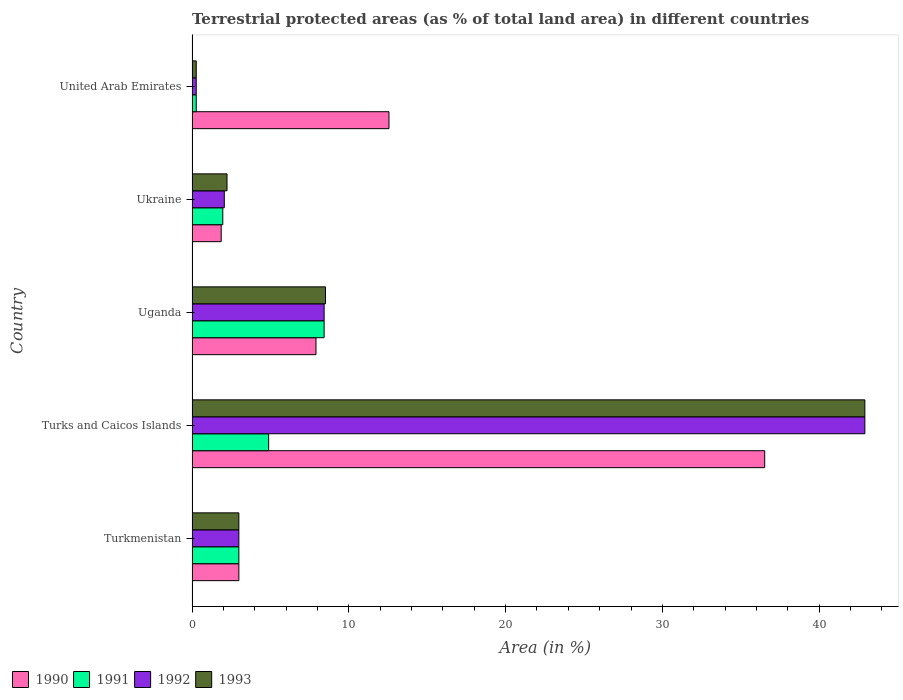Are the number of bars on each tick of the Y-axis equal?
Your answer should be very brief. Yes. How many bars are there on the 4th tick from the top?
Your answer should be compact. 4. How many bars are there on the 2nd tick from the bottom?
Give a very brief answer. 4. What is the label of the 1st group of bars from the top?
Make the answer very short. United Arab Emirates. In how many cases, is the number of bars for a given country not equal to the number of legend labels?
Provide a short and direct response. 0. What is the percentage of terrestrial protected land in 1990 in Uganda?
Your answer should be very brief. 7.91. Across all countries, what is the maximum percentage of terrestrial protected land in 1990?
Offer a terse response. 36.53. Across all countries, what is the minimum percentage of terrestrial protected land in 1992?
Make the answer very short. 0.27. In which country was the percentage of terrestrial protected land in 1990 maximum?
Offer a very short reply. Turks and Caicos Islands. In which country was the percentage of terrestrial protected land in 1992 minimum?
Provide a succinct answer. United Arab Emirates. What is the total percentage of terrestrial protected land in 1990 in the graph?
Give a very brief answer. 61.84. What is the difference between the percentage of terrestrial protected land in 1991 in Uganda and that in Ukraine?
Provide a short and direct response. 6.46. What is the difference between the percentage of terrestrial protected land in 1992 in Turkmenistan and the percentage of terrestrial protected land in 1990 in United Arab Emirates?
Ensure brevity in your answer.  -9.58. What is the average percentage of terrestrial protected land in 1993 per country?
Your answer should be very brief. 11.38. What is the difference between the percentage of terrestrial protected land in 1991 and percentage of terrestrial protected land in 1990 in Turkmenistan?
Provide a succinct answer. 1.6665444499963655e-6. In how many countries, is the percentage of terrestrial protected land in 1993 greater than 30 %?
Offer a very short reply. 1. What is the ratio of the percentage of terrestrial protected land in 1990 in Turks and Caicos Islands to that in Ukraine?
Offer a terse response. 19.65. Is the percentage of terrestrial protected land in 1993 in Turks and Caicos Islands less than that in United Arab Emirates?
Make the answer very short. No. Is the difference between the percentage of terrestrial protected land in 1991 in Turks and Caicos Islands and Uganda greater than the difference between the percentage of terrestrial protected land in 1990 in Turks and Caicos Islands and Uganda?
Your answer should be very brief. No. What is the difference between the highest and the second highest percentage of terrestrial protected land in 1990?
Your answer should be very brief. 23.97. What is the difference between the highest and the lowest percentage of terrestrial protected land in 1991?
Make the answer very short. 8.16. Is the sum of the percentage of terrestrial protected land in 1991 in Turkmenistan and Ukraine greater than the maximum percentage of terrestrial protected land in 1992 across all countries?
Ensure brevity in your answer.  No. Is it the case that in every country, the sum of the percentage of terrestrial protected land in 1992 and percentage of terrestrial protected land in 1990 is greater than the sum of percentage of terrestrial protected land in 1993 and percentage of terrestrial protected land in 1991?
Keep it short and to the point. No. Is it the case that in every country, the sum of the percentage of terrestrial protected land in 1991 and percentage of terrestrial protected land in 1993 is greater than the percentage of terrestrial protected land in 1992?
Ensure brevity in your answer.  Yes. How many countries are there in the graph?
Provide a short and direct response. 5. What is the difference between two consecutive major ticks on the X-axis?
Give a very brief answer. 10. Are the values on the major ticks of X-axis written in scientific E-notation?
Provide a short and direct response. No. How many legend labels are there?
Make the answer very short. 4. What is the title of the graph?
Give a very brief answer. Terrestrial protected areas (as % of total land area) in different countries. What is the label or title of the X-axis?
Ensure brevity in your answer.  Area (in %). What is the label or title of the Y-axis?
Your answer should be compact. Country. What is the Area (in %) of 1990 in Turkmenistan?
Offer a very short reply. 2.99. What is the Area (in %) of 1991 in Turkmenistan?
Ensure brevity in your answer.  2.99. What is the Area (in %) in 1992 in Turkmenistan?
Keep it short and to the point. 2.99. What is the Area (in %) of 1993 in Turkmenistan?
Keep it short and to the point. 2.99. What is the Area (in %) of 1990 in Turks and Caicos Islands?
Your response must be concise. 36.53. What is the Area (in %) of 1991 in Turks and Caicos Islands?
Your answer should be very brief. 4.89. What is the Area (in %) of 1992 in Turks and Caicos Islands?
Provide a succinct answer. 42.92. What is the Area (in %) of 1993 in Turks and Caicos Islands?
Keep it short and to the point. 42.92. What is the Area (in %) of 1990 in Uganda?
Give a very brief answer. 7.91. What is the Area (in %) of 1991 in Uganda?
Provide a succinct answer. 8.43. What is the Area (in %) in 1992 in Uganda?
Your answer should be compact. 8.43. What is the Area (in %) in 1993 in Uganda?
Your response must be concise. 8.51. What is the Area (in %) of 1990 in Ukraine?
Provide a succinct answer. 1.86. What is the Area (in %) in 1991 in Ukraine?
Offer a very short reply. 1.96. What is the Area (in %) in 1992 in Ukraine?
Make the answer very short. 2.06. What is the Area (in %) in 1993 in Ukraine?
Keep it short and to the point. 2.23. What is the Area (in %) in 1990 in United Arab Emirates?
Provide a succinct answer. 12.56. What is the Area (in %) in 1991 in United Arab Emirates?
Give a very brief answer. 0.27. What is the Area (in %) of 1992 in United Arab Emirates?
Your response must be concise. 0.27. What is the Area (in %) in 1993 in United Arab Emirates?
Make the answer very short. 0.27. Across all countries, what is the maximum Area (in %) in 1990?
Ensure brevity in your answer.  36.53. Across all countries, what is the maximum Area (in %) in 1991?
Keep it short and to the point. 8.43. Across all countries, what is the maximum Area (in %) of 1992?
Provide a succinct answer. 42.92. Across all countries, what is the maximum Area (in %) of 1993?
Make the answer very short. 42.92. Across all countries, what is the minimum Area (in %) in 1990?
Give a very brief answer. 1.86. Across all countries, what is the minimum Area (in %) in 1991?
Offer a terse response. 0.27. Across all countries, what is the minimum Area (in %) of 1992?
Ensure brevity in your answer.  0.27. Across all countries, what is the minimum Area (in %) in 1993?
Make the answer very short. 0.27. What is the total Area (in %) in 1990 in the graph?
Offer a terse response. 61.84. What is the total Area (in %) in 1991 in the graph?
Your answer should be compact. 18.53. What is the total Area (in %) of 1992 in the graph?
Your answer should be compact. 56.65. What is the total Area (in %) in 1993 in the graph?
Keep it short and to the point. 56.91. What is the difference between the Area (in %) in 1990 in Turkmenistan and that in Turks and Caicos Islands?
Your answer should be very brief. -33.54. What is the difference between the Area (in %) of 1991 in Turkmenistan and that in Turks and Caicos Islands?
Your answer should be compact. -1.9. What is the difference between the Area (in %) of 1992 in Turkmenistan and that in Turks and Caicos Islands?
Provide a succinct answer. -39.93. What is the difference between the Area (in %) in 1993 in Turkmenistan and that in Turks and Caicos Islands?
Ensure brevity in your answer.  -39.93. What is the difference between the Area (in %) of 1990 in Turkmenistan and that in Uganda?
Offer a terse response. -4.92. What is the difference between the Area (in %) of 1991 in Turkmenistan and that in Uganda?
Your response must be concise. -5.44. What is the difference between the Area (in %) in 1992 in Turkmenistan and that in Uganda?
Keep it short and to the point. -5.44. What is the difference between the Area (in %) in 1993 in Turkmenistan and that in Uganda?
Your answer should be very brief. -5.53. What is the difference between the Area (in %) of 1990 in Turkmenistan and that in Ukraine?
Give a very brief answer. 1.13. What is the difference between the Area (in %) of 1991 in Turkmenistan and that in Ukraine?
Make the answer very short. 1.02. What is the difference between the Area (in %) in 1992 in Turkmenistan and that in Ukraine?
Give a very brief answer. 0.93. What is the difference between the Area (in %) of 1993 in Turkmenistan and that in Ukraine?
Your answer should be compact. 0.76. What is the difference between the Area (in %) of 1990 in Turkmenistan and that in United Arab Emirates?
Ensure brevity in your answer.  -9.58. What is the difference between the Area (in %) of 1991 in Turkmenistan and that in United Arab Emirates?
Make the answer very short. 2.72. What is the difference between the Area (in %) in 1992 in Turkmenistan and that in United Arab Emirates?
Your response must be concise. 2.72. What is the difference between the Area (in %) in 1993 in Turkmenistan and that in United Arab Emirates?
Your response must be concise. 2.72. What is the difference between the Area (in %) of 1990 in Turks and Caicos Islands and that in Uganda?
Keep it short and to the point. 28.62. What is the difference between the Area (in %) in 1991 in Turks and Caicos Islands and that in Uganda?
Your response must be concise. -3.54. What is the difference between the Area (in %) in 1992 in Turks and Caicos Islands and that in Uganda?
Provide a short and direct response. 34.49. What is the difference between the Area (in %) of 1993 in Turks and Caicos Islands and that in Uganda?
Provide a short and direct response. 34.4. What is the difference between the Area (in %) in 1990 in Turks and Caicos Islands and that in Ukraine?
Make the answer very short. 34.67. What is the difference between the Area (in %) in 1991 in Turks and Caicos Islands and that in Ukraine?
Your answer should be very brief. 2.92. What is the difference between the Area (in %) in 1992 in Turks and Caicos Islands and that in Ukraine?
Your answer should be very brief. 40.86. What is the difference between the Area (in %) of 1993 in Turks and Caicos Islands and that in Ukraine?
Give a very brief answer. 40.69. What is the difference between the Area (in %) of 1990 in Turks and Caicos Islands and that in United Arab Emirates?
Your answer should be very brief. 23.97. What is the difference between the Area (in %) of 1991 in Turks and Caicos Islands and that in United Arab Emirates?
Offer a very short reply. 4.62. What is the difference between the Area (in %) of 1992 in Turks and Caicos Islands and that in United Arab Emirates?
Give a very brief answer. 42.65. What is the difference between the Area (in %) of 1993 in Turks and Caicos Islands and that in United Arab Emirates?
Make the answer very short. 42.65. What is the difference between the Area (in %) in 1990 in Uganda and that in Ukraine?
Give a very brief answer. 6.05. What is the difference between the Area (in %) of 1991 in Uganda and that in Ukraine?
Offer a very short reply. 6.46. What is the difference between the Area (in %) of 1992 in Uganda and that in Ukraine?
Your answer should be compact. 6.37. What is the difference between the Area (in %) of 1993 in Uganda and that in Ukraine?
Provide a succinct answer. 6.28. What is the difference between the Area (in %) of 1990 in Uganda and that in United Arab Emirates?
Give a very brief answer. -4.66. What is the difference between the Area (in %) of 1991 in Uganda and that in United Arab Emirates?
Your response must be concise. 8.16. What is the difference between the Area (in %) in 1992 in Uganda and that in United Arab Emirates?
Keep it short and to the point. 8.16. What is the difference between the Area (in %) in 1993 in Uganda and that in United Arab Emirates?
Make the answer very short. 8.25. What is the difference between the Area (in %) of 1990 in Ukraine and that in United Arab Emirates?
Give a very brief answer. -10.7. What is the difference between the Area (in %) in 1991 in Ukraine and that in United Arab Emirates?
Keep it short and to the point. 1.69. What is the difference between the Area (in %) in 1992 in Ukraine and that in United Arab Emirates?
Offer a very short reply. 1.79. What is the difference between the Area (in %) in 1993 in Ukraine and that in United Arab Emirates?
Offer a very short reply. 1.96. What is the difference between the Area (in %) of 1990 in Turkmenistan and the Area (in %) of 1991 in Turks and Caicos Islands?
Give a very brief answer. -1.9. What is the difference between the Area (in %) in 1990 in Turkmenistan and the Area (in %) in 1992 in Turks and Caicos Islands?
Your answer should be compact. -39.93. What is the difference between the Area (in %) of 1990 in Turkmenistan and the Area (in %) of 1993 in Turks and Caicos Islands?
Make the answer very short. -39.93. What is the difference between the Area (in %) of 1991 in Turkmenistan and the Area (in %) of 1992 in Turks and Caicos Islands?
Provide a short and direct response. -39.93. What is the difference between the Area (in %) of 1991 in Turkmenistan and the Area (in %) of 1993 in Turks and Caicos Islands?
Offer a terse response. -39.93. What is the difference between the Area (in %) in 1992 in Turkmenistan and the Area (in %) in 1993 in Turks and Caicos Islands?
Offer a very short reply. -39.93. What is the difference between the Area (in %) of 1990 in Turkmenistan and the Area (in %) of 1991 in Uganda?
Provide a short and direct response. -5.44. What is the difference between the Area (in %) of 1990 in Turkmenistan and the Area (in %) of 1992 in Uganda?
Give a very brief answer. -5.44. What is the difference between the Area (in %) of 1990 in Turkmenistan and the Area (in %) of 1993 in Uganda?
Offer a terse response. -5.53. What is the difference between the Area (in %) in 1991 in Turkmenistan and the Area (in %) in 1992 in Uganda?
Your answer should be very brief. -5.44. What is the difference between the Area (in %) in 1991 in Turkmenistan and the Area (in %) in 1993 in Uganda?
Ensure brevity in your answer.  -5.53. What is the difference between the Area (in %) in 1992 in Turkmenistan and the Area (in %) in 1993 in Uganda?
Provide a succinct answer. -5.53. What is the difference between the Area (in %) of 1990 in Turkmenistan and the Area (in %) of 1991 in Ukraine?
Provide a short and direct response. 1.02. What is the difference between the Area (in %) of 1990 in Turkmenistan and the Area (in %) of 1992 in Ukraine?
Ensure brevity in your answer.  0.93. What is the difference between the Area (in %) in 1990 in Turkmenistan and the Area (in %) in 1993 in Ukraine?
Ensure brevity in your answer.  0.76. What is the difference between the Area (in %) in 1991 in Turkmenistan and the Area (in %) in 1992 in Ukraine?
Keep it short and to the point. 0.93. What is the difference between the Area (in %) of 1991 in Turkmenistan and the Area (in %) of 1993 in Ukraine?
Offer a terse response. 0.76. What is the difference between the Area (in %) in 1992 in Turkmenistan and the Area (in %) in 1993 in Ukraine?
Make the answer very short. 0.76. What is the difference between the Area (in %) of 1990 in Turkmenistan and the Area (in %) of 1991 in United Arab Emirates?
Keep it short and to the point. 2.72. What is the difference between the Area (in %) in 1990 in Turkmenistan and the Area (in %) in 1992 in United Arab Emirates?
Provide a short and direct response. 2.72. What is the difference between the Area (in %) in 1990 in Turkmenistan and the Area (in %) in 1993 in United Arab Emirates?
Keep it short and to the point. 2.72. What is the difference between the Area (in %) of 1991 in Turkmenistan and the Area (in %) of 1992 in United Arab Emirates?
Provide a succinct answer. 2.72. What is the difference between the Area (in %) in 1991 in Turkmenistan and the Area (in %) in 1993 in United Arab Emirates?
Provide a short and direct response. 2.72. What is the difference between the Area (in %) of 1992 in Turkmenistan and the Area (in %) of 1993 in United Arab Emirates?
Provide a short and direct response. 2.72. What is the difference between the Area (in %) of 1990 in Turks and Caicos Islands and the Area (in %) of 1991 in Uganda?
Offer a terse response. 28.1. What is the difference between the Area (in %) in 1990 in Turks and Caicos Islands and the Area (in %) in 1992 in Uganda?
Ensure brevity in your answer.  28.1. What is the difference between the Area (in %) in 1990 in Turks and Caicos Islands and the Area (in %) in 1993 in Uganda?
Give a very brief answer. 28.02. What is the difference between the Area (in %) of 1991 in Turks and Caicos Islands and the Area (in %) of 1992 in Uganda?
Your answer should be compact. -3.54. What is the difference between the Area (in %) in 1991 in Turks and Caicos Islands and the Area (in %) in 1993 in Uganda?
Provide a succinct answer. -3.63. What is the difference between the Area (in %) in 1992 in Turks and Caicos Islands and the Area (in %) in 1993 in Uganda?
Your response must be concise. 34.4. What is the difference between the Area (in %) of 1990 in Turks and Caicos Islands and the Area (in %) of 1991 in Ukraine?
Keep it short and to the point. 34.57. What is the difference between the Area (in %) in 1990 in Turks and Caicos Islands and the Area (in %) in 1992 in Ukraine?
Offer a very short reply. 34.47. What is the difference between the Area (in %) of 1990 in Turks and Caicos Islands and the Area (in %) of 1993 in Ukraine?
Your answer should be compact. 34.3. What is the difference between the Area (in %) in 1991 in Turks and Caicos Islands and the Area (in %) in 1992 in Ukraine?
Your response must be concise. 2.83. What is the difference between the Area (in %) of 1991 in Turks and Caicos Islands and the Area (in %) of 1993 in Ukraine?
Give a very brief answer. 2.66. What is the difference between the Area (in %) in 1992 in Turks and Caicos Islands and the Area (in %) in 1993 in Ukraine?
Your answer should be compact. 40.69. What is the difference between the Area (in %) in 1990 in Turks and Caicos Islands and the Area (in %) in 1991 in United Arab Emirates?
Provide a short and direct response. 36.26. What is the difference between the Area (in %) in 1990 in Turks and Caicos Islands and the Area (in %) in 1992 in United Arab Emirates?
Your answer should be very brief. 36.26. What is the difference between the Area (in %) in 1990 in Turks and Caicos Islands and the Area (in %) in 1993 in United Arab Emirates?
Give a very brief answer. 36.26. What is the difference between the Area (in %) of 1991 in Turks and Caicos Islands and the Area (in %) of 1992 in United Arab Emirates?
Keep it short and to the point. 4.62. What is the difference between the Area (in %) in 1991 in Turks and Caicos Islands and the Area (in %) in 1993 in United Arab Emirates?
Offer a terse response. 4.62. What is the difference between the Area (in %) of 1992 in Turks and Caicos Islands and the Area (in %) of 1993 in United Arab Emirates?
Make the answer very short. 42.65. What is the difference between the Area (in %) of 1990 in Uganda and the Area (in %) of 1991 in Ukraine?
Provide a short and direct response. 5.94. What is the difference between the Area (in %) of 1990 in Uganda and the Area (in %) of 1992 in Ukraine?
Offer a very short reply. 5.85. What is the difference between the Area (in %) in 1990 in Uganda and the Area (in %) in 1993 in Ukraine?
Offer a terse response. 5.68. What is the difference between the Area (in %) in 1991 in Uganda and the Area (in %) in 1992 in Ukraine?
Offer a terse response. 6.37. What is the difference between the Area (in %) in 1991 in Uganda and the Area (in %) in 1993 in Ukraine?
Give a very brief answer. 6.19. What is the difference between the Area (in %) in 1992 in Uganda and the Area (in %) in 1993 in Ukraine?
Offer a very short reply. 6.19. What is the difference between the Area (in %) in 1990 in Uganda and the Area (in %) in 1991 in United Arab Emirates?
Offer a very short reply. 7.64. What is the difference between the Area (in %) in 1990 in Uganda and the Area (in %) in 1992 in United Arab Emirates?
Your answer should be very brief. 7.64. What is the difference between the Area (in %) in 1990 in Uganda and the Area (in %) in 1993 in United Arab Emirates?
Provide a succinct answer. 7.64. What is the difference between the Area (in %) in 1991 in Uganda and the Area (in %) in 1992 in United Arab Emirates?
Ensure brevity in your answer.  8.16. What is the difference between the Area (in %) of 1991 in Uganda and the Area (in %) of 1993 in United Arab Emirates?
Offer a very short reply. 8.16. What is the difference between the Area (in %) of 1992 in Uganda and the Area (in %) of 1993 in United Arab Emirates?
Give a very brief answer. 8.16. What is the difference between the Area (in %) of 1990 in Ukraine and the Area (in %) of 1991 in United Arab Emirates?
Give a very brief answer. 1.59. What is the difference between the Area (in %) in 1990 in Ukraine and the Area (in %) in 1992 in United Arab Emirates?
Keep it short and to the point. 1.59. What is the difference between the Area (in %) in 1990 in Ukraine and the Area (in %) in 1993 in United Arab Emirates?
Give a very brief answer. 1.59. What is the difference between the Area (in %) in 1991 in Ukraine and the Area (in %) in 1992 in United Arab Emirates?
Keep it short and to the point. 1.69. What is the difference between the Area (in %) in 1991 in Ukraine and the Area (in %) in 1993 in United Arab Emirates?
Your answer should be very brief. 1.69. What is the difference between the Area (in %) of 1992 in Ukraine and the Area (in %) of 1993 in United Arab Emirates?
Your answer should be compact. 1.79. What is the average Area (in %) in 1990 per country?
Your answer should be compact. 12.37. What is the average Area (in %) in 1991 per country?
Keep it short and to the point. 3.71. What is the average Area (in %) in 1992 per country?
Your answer should be very brief. 11.33. What is the average Area (in %) of 1993 per country?
Provide a succinct answer. 11.38. What is the difference between the Area (in %) of 1990 and Area (in %) of 1991 in Turkmenistan?
Provide a short and direct response. -0. What is the difference between the Area (in %) in 1990 and Area (in %) in 1992 in Turkmenistan?
Give a very brief answer. -0. What is the difference between the Area (in %) of 1992 and Area (in %) of 1993 in Turkmenistan?
Make the answer very short. 0. What is the difference between the Area (in %) in 1990 and Area (in %) in 1991 in Turks and Caicos Islands?
Provide a short and direct response. 31.64. What is the difference between the Area (in %) of 1990 and Area (in %) of 1992 in Turks and Caicos Islands?
Your response must be concise. -6.39. What is the difference between the Area (in %) of 1990 and Area (in %) of 1993 in Turks and Caicos Islands?
Keep it short and to the point. -6.39. What is the difference between the Area (in %) in 1991 and Area (in %) in 1992 in Turks and Caicos Islands?
Provide a succinct answer. -38.03. What is the difference between the Area (in %) in 1991 and Area (in %) in 1993 in Turks and Caicos Islands?
Your answer should be very brief. -38.03. What is the difference between the Area (in %) in 1992 and Area (in %) in 1993 in Turks and Caicos Islands?
Offer a terse response. 0. What is the difference between the Area (in %) in 1990 and Area (in %) in 1991 in Uganda?
Ensure brevity in your answer.  -0.52. What is the difference between the Area (in %) of 1990 and Area (in %) of 1992 in Uganda?
Make the answer very short. -0.52. What is the difference between the Area (in %) of 1990 and Area (in %) of 1993 in Uganda?
Your answer should be very brief. -0.61. What is the difference between the Area (in %) in 1991 and Area (in %) in 1993 in Uganda?
Keep it short and to the point. -0.09. What is the difference between the Area (in %) of 1992 and Area (in %) of 1993 in Uganda?
Your answer should be compact. -0.09. What is the difference between the Area (in %) in 1990 and Area (in %) in 1991 in Ukraine?
Your answer should be very brief. -0.1. What is the difference between the Area (in %) of 1990 and Area (in %) of 1992 in Ukraine?
Offer a terse response. -0.2. What is the difference between the Area (in %) in 1990 and Area (in %) in 1993 in Ukraine?
Your response must be concise. -0.37. What is the difference between the Area (in %) in 1991 and Area (in %) in 1992 in Ukraine?
Provide a short and direct response. -0.1. What is the difference between the Area (in %) of 1991 and Area (in %) of 1993 in Ukraine?
Make the answer very short. -0.27. What is the difference between the Area (in %) in 1992 and Area (in %) in 1993 in Ukraine?
Your response must be concise. -0.17. What is the difference between the Area (in %) in 1990 and Area (in %) in 1991 in United Arab Emirates?
Offer a very short reply. 12.3. What is the difference between the Area (in %) of 1990 and Area (in %) of 1992 in United Arab Emirates?
Keep it short and to the point. 12.3. What is the difference between the Area (in %) of 1990 and Area (in %) of 1993 in United Arab Emirates?
Offer a very short reply. 12.29. What is the difference between the Area (in %) in 1991 and Area (in %) in 1993 in United Arab Emirates?
Ensure brevity in your answer.  -0. What is the difference between the Area (in %) of 1992 and Area (in %) of 1993 in United Arab Emirates?
Give a very brief answer. -0. What is the ratio of the Area (in %) of 1990 in Turkmenistan to that in Turks and Caicos Islands?
Your answer should be compact. 0.08. What is the ratio of the Area (in %) of 1991 in Turkmenistan to that in Turks and Caicos Islands?
Your answer should be compact. 0.61. What is the ratio of the Area (in %) in 1992 in Turkmenistan to that in Turks and Caicos Islands?
Provide a succinct answer. 0.07. What is the ratio of the Area (in %) of 1993 in Turkmenistan to that in Turks and Caicos Islands?
Your response must be concise. 0.07. What is the ratio of the Area (in %) in 1990 in Turkmenistan to that in Uganda?
Ensure brevity in your answer.  0.38. What is the ratio of the Area (in %) of 1991 in Turkmenistan to that in Uganda?
Ensure brevity in your answer.  0.35. What is the ratio of the Area (in %) in 1992 in Turkmenistan to that in Uganda?
Ensure brevity in your answer.  0.35. What is the ratio of the Area (in %) of 1993 in Turkmenistan to that in Uganda?
Your answer should be very brief. 0.35. What is the ratio of the Area (in %) in 1990 in Turkmenistan to that in Ukraine?
Keep it short and to the point. 1.61. What is the ratio of the Area (in %) of 1991 in Turkmenistan to that in Ukraine?
Make the answer very short. 1.52. What is the ratio of the Area (in %) of 1992 in Turkmenistan to that in Ukraine?
Ensure brevity in your answer.  1.45. What is the ratio of the Area (in %) of 1993 in Turkmenistan to that in Ukraine?
Your answer should be very brief. 1.34. What is the ratio of the Area (in %) in 1990 in Turkmenistan to that in United Arab Emirates?
Ensure brevity in your answer.  0.24. What is the ratio of the Area (in %) in 1991 in Turkmenistan to that in United Arab Emirates?
Keep it short and to the point. 11.19. What is the ratio of the Area (in %) in 1992 in Turkmenistan to that in United Arab Emirates?
Provide a succinct answer. 11.19. What is the ratio of the Area (in %) of 1993 in Turkmenistan to that in United Arab Emirates?
Provide a short and direct response. 11.16. What is the ratio of the Area (in %) of 1990 in Turks and Caicos Islands to that in Uganda?
Make the answer very short. 4.62. What is the ratio of the Area (in %) in 1991 in Turks and Caicos Islands to that in Uganda?
Give a very brief answer. 0.58. What is the ratio of the Area (in %) of 1992 in Turks and Caicos Islands to that in Uganda?
Provide a short and direct response. 5.09. What is the ratio of the Area (in %) in 1993 in Turks and Caicos Islands to that in Uganda?
Offer a terse response. 5.04. What is the ratio of the Area (in %) of 1990 in Turks and Caicos Islands to that in Ukraine?
Keep it short and to the point. 19.65. What is the ratio of the Area (in %) of 1991 in Turks and Caicos Islands to that in Ukraine?
Ensure brevity in your answer.  2.49. What is the ratio of the Area (in %) in 1992 in Turks and Caicos Islands to that in Ukraine?
Keep it short and to the point. 20.86. What is the ratio of the Area (in %) in 1993 in Turks and Caicos Islands to that in Ukraine?
Keep it short and to the point. 19.24. What is the ratio of the Area (in %) in 1990 in Turks and Caicos Islands to that in United Arab Emirates?
Offer a very short reply. 2.91. What is the ratio of the Area (in %) in 1991 in Turks and Caicos Islands to that in United Arab Emirates?
Ensure brevity in your answer.  18.31. What is the ratio of the Area (in %) of 1992 in Turks and Caicos Islands to that in United Arab Emirates?
Your response must be concise. 160.81. What is the ratio of the Area (in %) in 1993 in Turks and Caicos Islands to that in United Arab Emirates?
Ensure brevity in your answer.  160.37. What is the ratio of the Area (in %) in 1990 in Uganda to that in Ukraine?
Give a very brief answer. 4.25. What is the ratio of the Area (in %) in 1991 in Uganda to that in Ukraine?
Provide a short and direct response. 4.29. What is the ratio of the Area (in %) of 1992 in Uganda to that in Ukraine?
Ensure brevity in your answer.  4.09. What is the ratio of the Area (in %) in 1993 in Uganda to that in Ukraine?
Ensure brevity in your answer.  3.82. What is the ratio of the Area (in %) in 1990 in Uganda to that in United Arab Emirates?
Ensure brevity in your answer.  0.63. What is the ratio of the Area (in %) in 1991 in Uganda to that in United Arab Emirates?
Give a very brief answer. 31.57. What is the ratio of the Area (in %) of 1992 in Uganda to that in United Arab Emirates?
Provide a short and direct response. 31.57. What is the ratio of the Area (in %) of 1993 in Uganda to that in United Arab Emirates?
Give a very brief answer. 31.81. What is the ratio of the Area (in %) in 1990 in Ukraine to that in United Arab Emirates?
Provide a short and direct response. 0.15. What is the ratio of the Area (in %) in 1991 in Ukraine to that in United Arab Emirates?
Keep it short and to the point. 7.35. What is the ratio of the Area (in %) of 1992 in Ukraine to that in United Arab Emirates?
Your answer should be very brief. 7.71. What is the ratio of the Area (in %) of 1993 in Ukraine to that in United Arab Emirates?
Offer a terse response. 8.33. What is the difference between the highest and the second highest Area (in %) in 1990?
Give a very brief answer. 23.97. What is the difference between the highest and the second highest Area (in %) of 1991?
Keep it short and to the point. 3.54. What is the difference between the highest and the second highest Area (in %) of 1992?
Your answer should be very brief. 34.49. What is the difference between the highest and the second highest Area (in %) of 1993?
Your answer should be compact. 34.4. What is the difference between the highest and the lowest Area (in %) in 1990?
Your answer should be compact. 34.67. What is the difference between the highest and the lowest Area (in %) in 1991?
Provide a succinct answer. 8.16. What is the difference between the highest and the lowest Area (in %) of 1992?
Your answer should be very brief. 42.65. What is the difference between the highest and the lowest Area (in %) in 1993?
Your response must be concise. 42.65. 